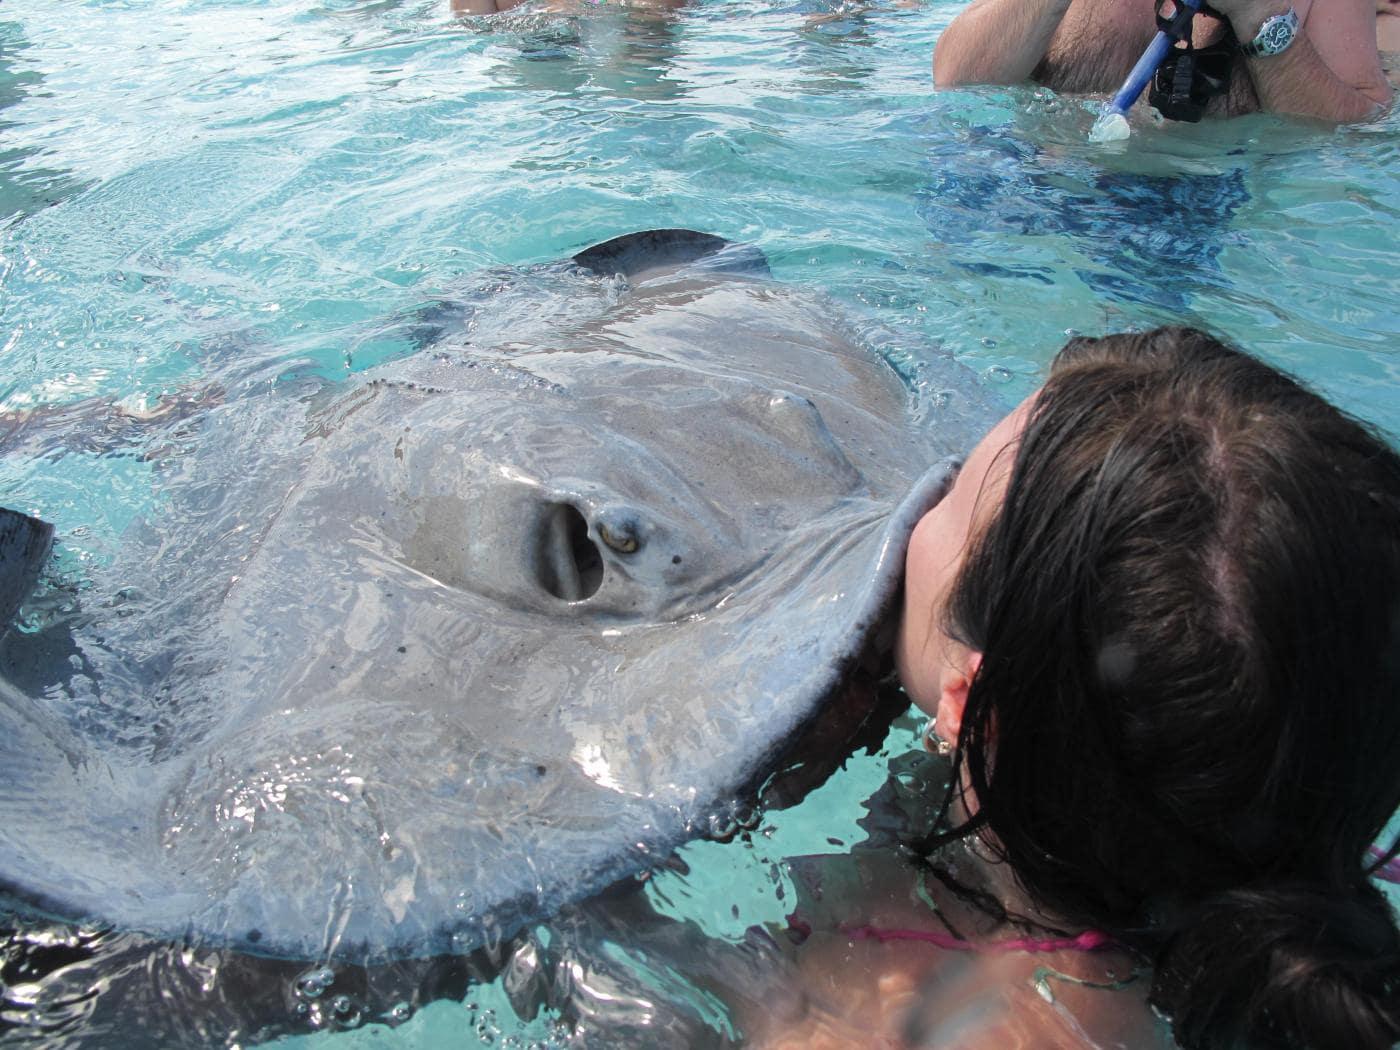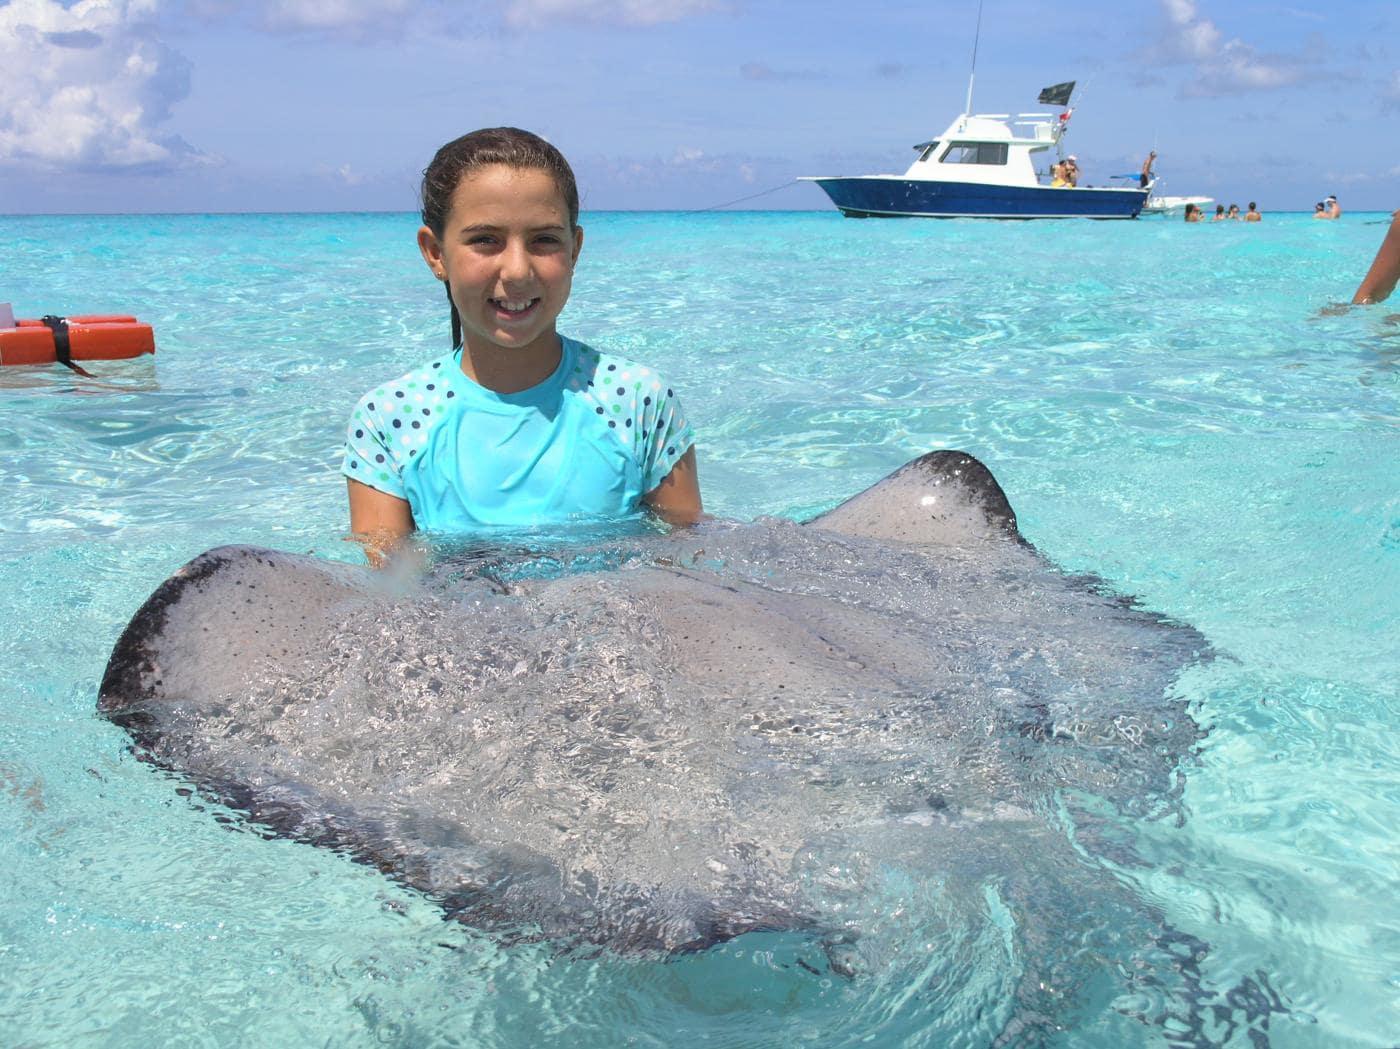The first image is the image on the left, the second image is the image on the right. Examine the images to the left and right. Is the description "One image shows one person with goggles completely underwater near stingrays." accurate? Answer yes or no. No. The first image is the image on the left, the second image is the image on the right. Considering the images on both sides, is "One or more large flat fish is interacting with one or more people." valid? Answer yes or no. Yes. 